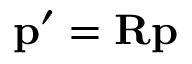Convert formula to latex. <formula><loc_0><loc_0><loc_500><loc_500>p ^ { \prime } = R p</formula> 